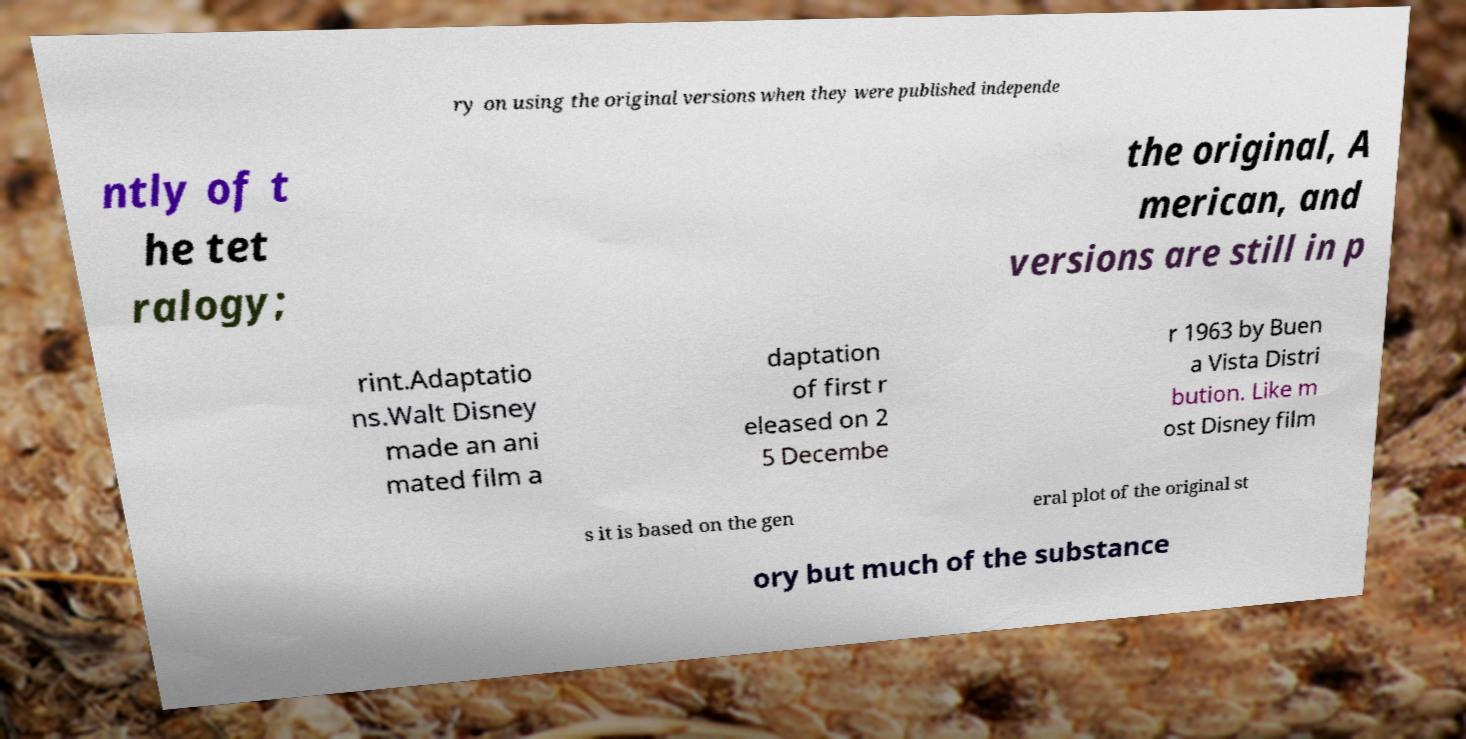What messages or text are displayed in this image? I need them in a readable, typed format. ry on using the original versions when they were published independe ntly of t he tet ralogy; the original, A merican, and versions are still in p rint.Adaptatio ns.Walt Disney made an ani mated film a daptation of first r eleased on 2 5 Decembe r 1963 by Buen a Vista Distri bution. Like m ost Disney film s it is based on the gen eral plot of the original st ory but much of the substance 